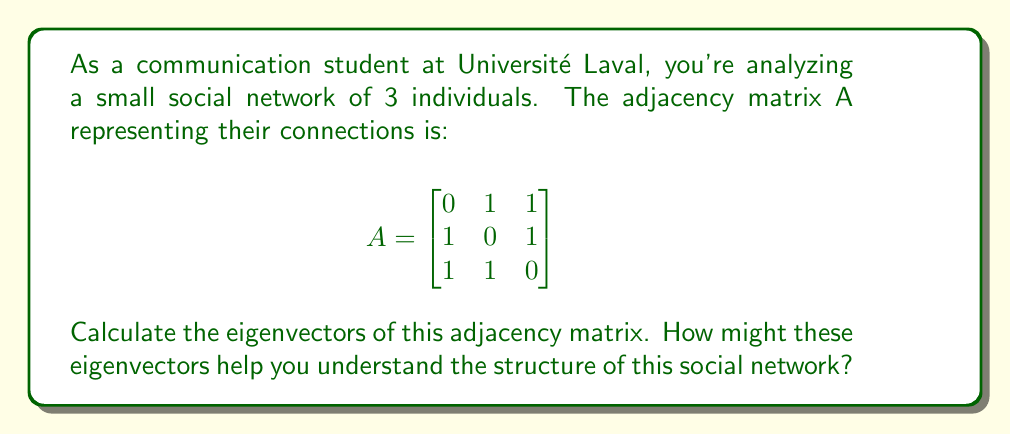Help me with this question. To find the eigenvectors of the adjacency matrix A, we follow these steps:

1) First, we need to find the eigenvalues by solving the characteristic equation:
   $det(A - \lambda I) = 0$

   $$ \begin{vmatrix}
   -\lambda & 1 & 1 \\
   1 & -\lambda & 1 \\
   1 & 1 & -\lambda
   \end{vmatrix} = 0 $$

2) Expanding this determinant:
   $-\lambda^3 + 3\lambda + 2 = 0$

3) Solving this equation, we get the eigenvalues:
   $\lambda_1 = 2$, $\lambda_2 = \lambda_3 = -1$

4) Now, for each eigenvalue, we solve $(A - \lambda I)v = 0$ to find the corresponding eigenvector.

For $\lambda_1 = 2$:
$$ \begin{bmatrix}
-2 & 1 & 1 \\
1 & -2 & 1 \\
1 & 1 & -2
\end{bmatrix} \begin{bmatrix} v_1 \\ v_2 \\ v_3 \end{bmatrix} = \begin{bmatrix} 0 \\ 0 \\ 0 \end{bmatrix} $$

Solving this system, we get $v_1 = v_2 = v_3$. We can choose $v_1 = \begin{bmatrix} 1 \\ 1 \\ 1 \end{bmatrix}$.

For $\lambda_2 = \lambda_3 = -1$:
$$ \begin{bmatrix}
1 & 1 & 1 \\
1 & 1 & 1 \\
1 & 1 & 1
\end{bmatrix} \begin{bmatrix} v_1 \\ v_2 \\ v_3 \end{bmatrix} = \begin{bmatrix} 0 \\ 0 \\ 0 \end{bmatrix} $$

This gives us $v_1 + v_2 + v_3 = 0$. Two linearly independent solutions are:
$v_2 = \begin{bmatrix} 1 \\ -1 \\ 0 \end{bmatrix}$ and $v_3 = \begin{bmatrix} 1 \\ 0 \\ -1 \end{bmatrix}$.

In the context of social networks, the eigenvector corresponding to the largest eigenvalue (2 in this case) is particularly important. It's known as the eigenvector centrality and gives a measure of each node's influence in the network. In this case, all nodes have equal influence, which is expected in a fully connected network of 3 nodes.

The other eigenvectors can provide information about community structure within the network, although in this small example, there isn't much community structure to detect.
Answer: The eigenvectors of the adjacency matrix are:

$v_1 = \begin{bmatrix} 1 \\ 1 \\ 1 \end{bmatrix}$ (corresponding to $\lambda_1 = 2$)

$v_2 = \begin{bmatrix} 1 \\ -1 \\ 0 \end{bmatrix}$ and $v_3 = \begin{bmatrix} 1 \\ 0 \\ -1 \end{bmatrix}$ (corresponding to $\lambda_2 = \lambda_3 = -1$)

These eigenvectors, particularly $v_1$, can help understand the network structure by providing information about node centrality and potential community divisions. 